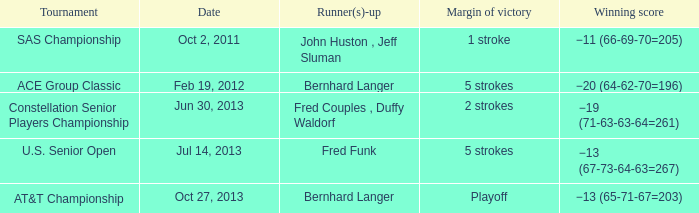Write the full table. {'header': ['Tournament', 'Date', 'Runner(s)-up', 'Margin of victory', 'Winning score'], 'rows': [['SAS Championship', 'Oct 2, 2011', 'John Huston , Jeff Sluman', '1 stroke', '−11 (66-69-70=205)'], ['ACE Group Classic', 'Feb 19, 2012', 'Bernhard Langer', '5 strokes', '−20 (64-62-70=196)'], ['Constellation Senior Players Championship', 'Jun 30, 2013', 'Fred Couples , Duffy Waldorf', '2 strokes', '−19 (71-63-63-64=261)'], ['U.S. Senior Open', 'Jul 14, 2013', 'Fred Funk', '5 strokes', '−13 (67-73-64-63=267)'], ['AT&T Championship', 'Oct 27, 2013', 'Bernhard Langer', 'Playoff', '−13 (65-71-67=203)']]} Which Date has a Runner(s)-up of bernhard langer, and a Tournament of at&t championship? Oct 27, 2013. 